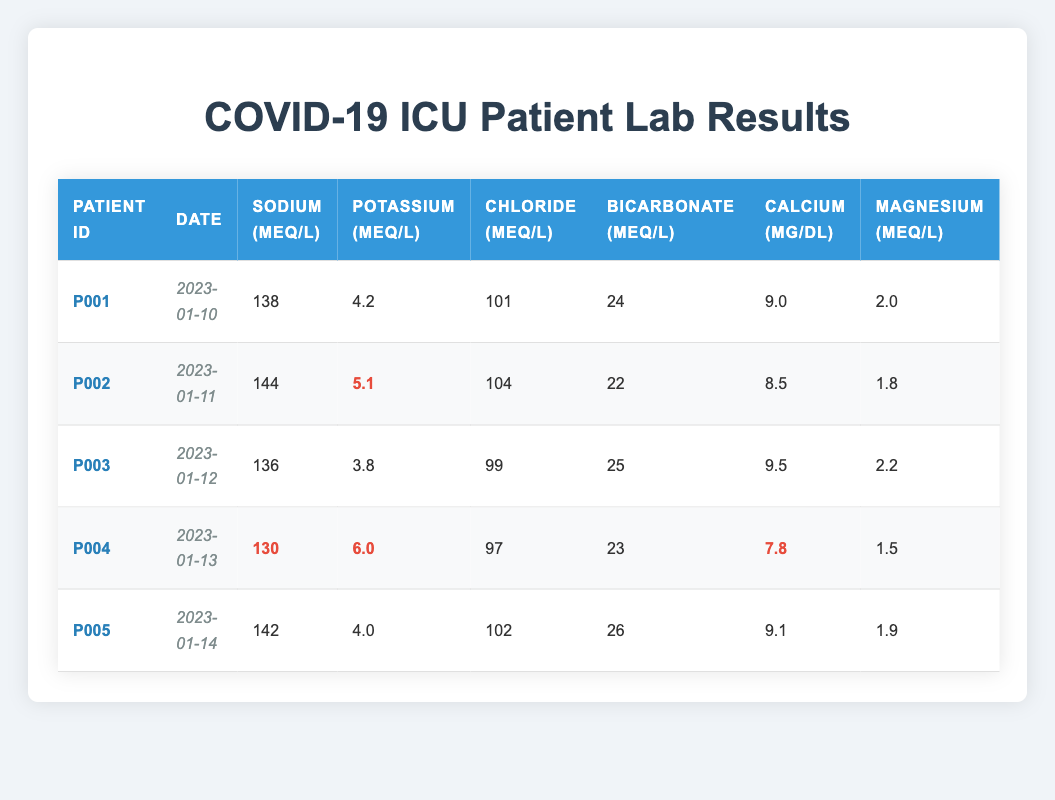What is the Sodium level for Patient P002? Looking at the row for Patient P002, the Sodium level is listed as 144 mEq/L.
Answer: 144 mEq/L Which patient has the lowest Calcium level? Reviewing the Calcium levels for each patient, Patient P004 has the lowest value of 7.8 mg/dL.
Answer: Patient P004 Is Patient P001's Bicarbonate level within the normal range (22-28 mEq/L)? Patient P001 has a Bicarbonate level of 24 mEq/L, which falls within the normal range of 22-28 mEq/L.
Answer: Yes What is the difference in Potassium levels between Patient P004 and Patient P002? Patient P004 has a Potassium level of 6.0 mEq/L, while Patient P002 has a level of 5.1 mEq/L. The difference is 6.0 - 5.1 = 0.9 mEq/L.
Answer: 0.9 mEq/L What is the average Magnesium level among all patients? The Magnesium levels are 2.0, 1.8, 2.2, 1.5, and 1.9 mEq/L. Adding them gives 2.0 + 1.8 + 2.2 + 1.5 + 1.9 = 9.4 mEq/L. To find the average, divide by 5 (the number of patients): 9.4 / 5 = 1.88 mEq/L.
Answer: 1.88 mEq/L Is it true that Patient P003 has normal Sodium levels? Patient P003 has a Sodium level of 136 mEq/L, which is typically considered to be low (normal range is 135-145 mEq/L). Therefore, it is not true that their Sodium levels are normal.
Answer: No Which patient had their lab results taken on January 13? The lab results for January 13 are for Patient P004.
Answer: Patient P004 What is the highest Chloride level recorded? The Chloride levels are 101, 104, 99, 97, and 102 mEq/L. The highest value is 104 mEq/L for Patient P002.
Answer: 104 mEq/L How many patients have a Potassium level above 5.0 mEq/L? The Potassium levels are 4.2, 5.1, 3.8, 6.0, and 4.0 mEq/L. Only Patients P002 and P004 have levels above 5.0 mEq/L, so there are 2 patients.
Answer: 2 